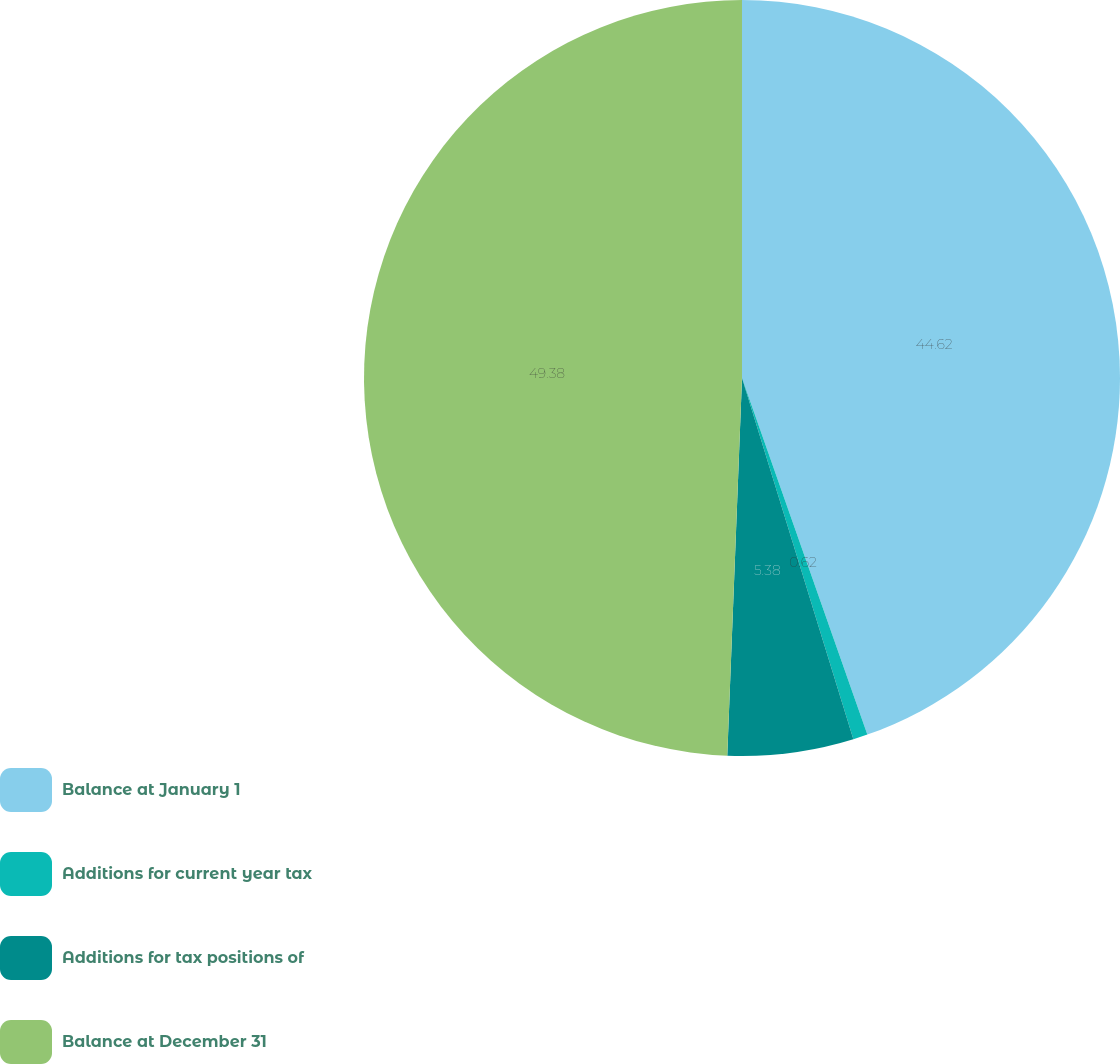Convert chart to OTSL. <chart><loc_0><loc_0><loc_500><loc_500><pie_chart><fcel>Balance at January 1<fcel>Additions for current year tax<fcel>Additions for tax positions of<fcel>Balance at December 31<nl><fcel>44.62%<fcel>0.62%<fcel>5.38%<fcel>49.38%<nl></chart> 